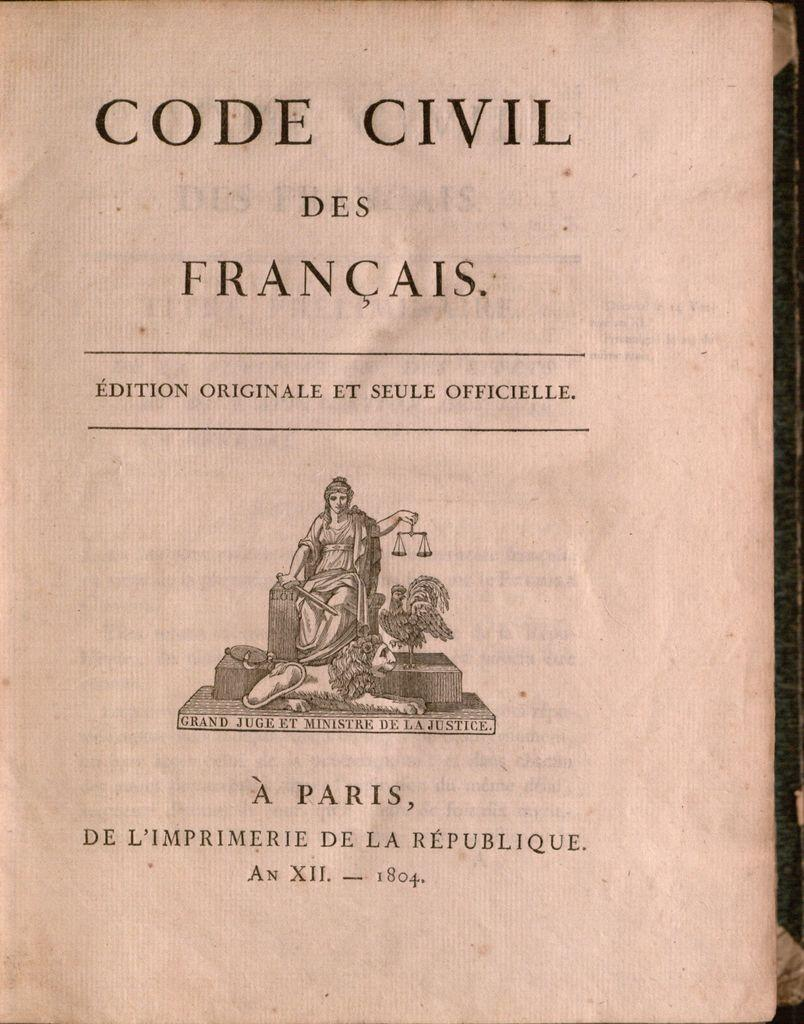<image>
Write a terse but informative summary of the picture. A old text book about Civil Code from Paris. 